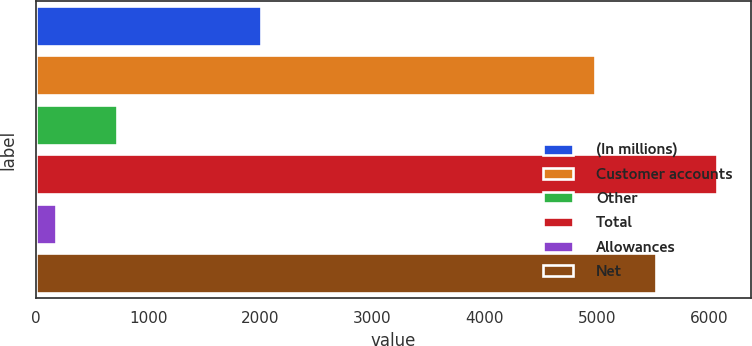Convert chart to OTSL. <chart><loc_0><loc_0><loc_500><loc_500><bar_chart><fcel>(In millions)<fcel>Customer accounts<fcel>Other<fcel>Total<fcel>Allowances<fcel>Net<nl><fcel>2004<fcel>4986.1<fcel>718.68<fcel>6069.86<fcel>176.8<fcel>5527.98<nl></chart> 